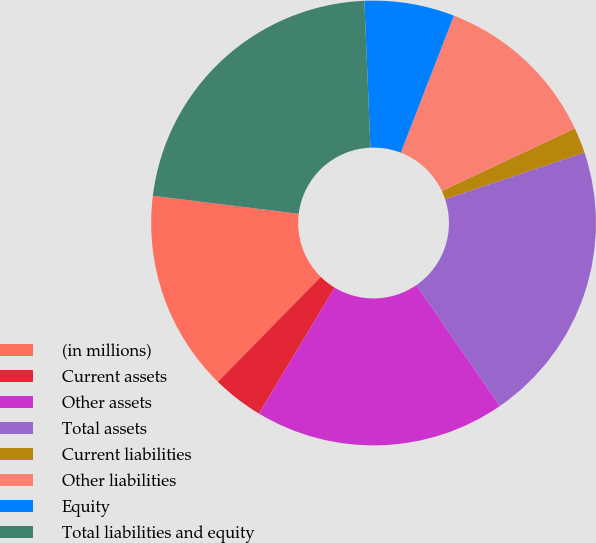<chart> <loc_0><loc_0><loc_500><loc_500><pie_chart><fcel>(in millions)<fcel>Current assets<fcel>Other assets<fcel>Total assets<fcel>Current liabilities<fcel>Other liabilities<fcel>Equity<fcel>Total liabilities and equity<nl><fcel>14.61%<fcel>3.72%<fcel>18.24%<fcel>20.52%<fcel>1.85%<fcel>12.13%<fcel>6.54%<fcel>22.39%<nl></chart> 